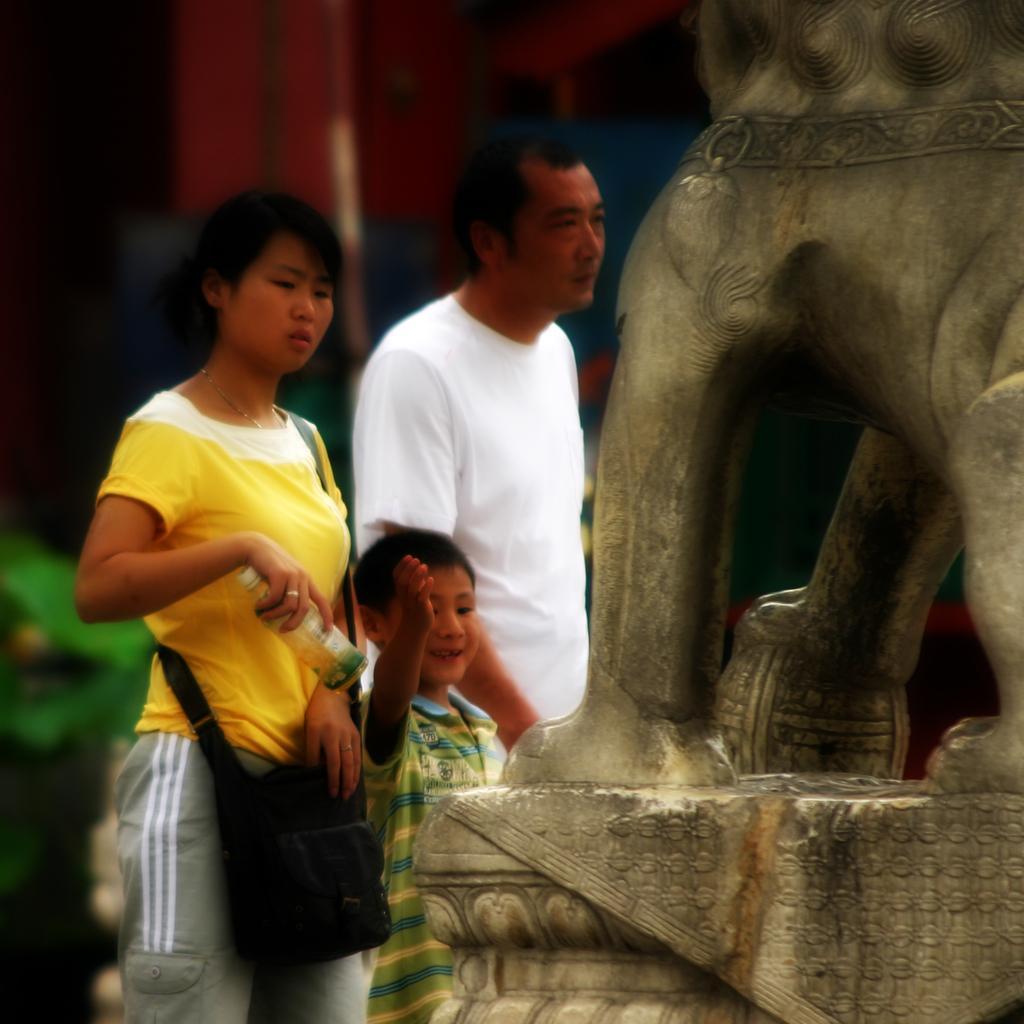Please provide a concise description of this image. In this picture we can see three people standing near to a statue. Here we can see this woman holding a bottle with her hand. This is a bag in black color. Background portion of the picture is blur. 